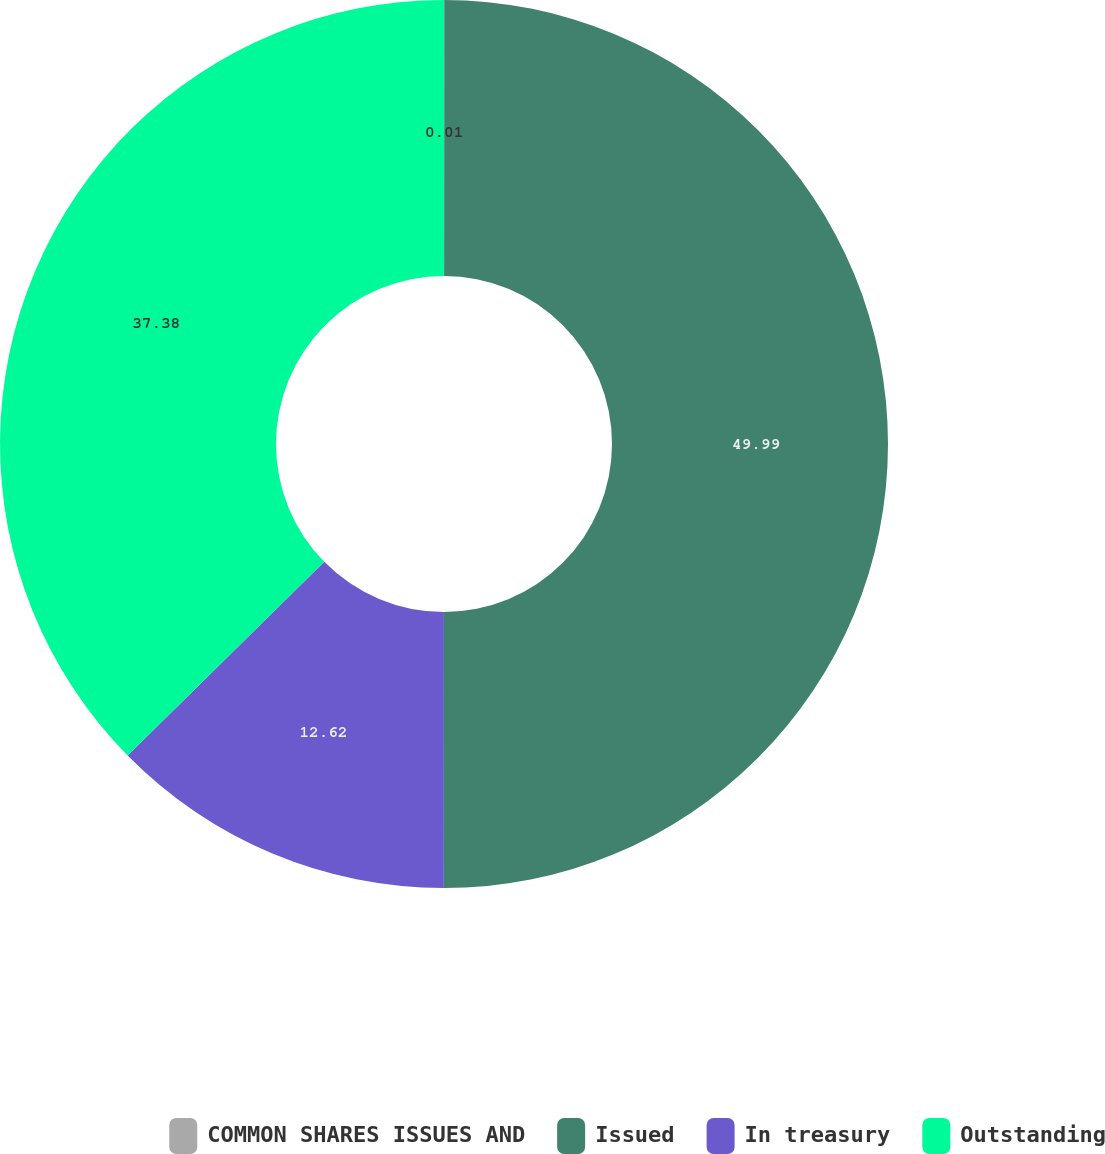<chart> <loc_0><loc_0><loc_500><loc_500><pie_chart><fcel>COMMON SHARES ISSUES AND<fcel>Issued<fcel>In treasury<fcel>Outstanding<nl><fcel>0.01%<fcel>50.0%<fcel>12.62%<fcel>37.38%<nl></chart> 